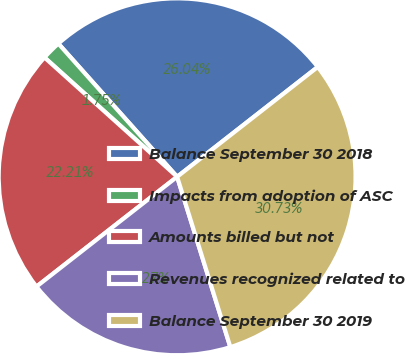Convert chart to OTSL. <chart><loc_0><loc_0><loc_500><loc_500><pie_chart><fcel>Balance September 30 2018<fcel>Impacts from adoption of ASC<fcel>Amounts billed but not<fcel>Revenues recognized related to<fcel>Balance September 30 2019<nl><fcel>26.04%<fcel>1.75%<fcel>22.21%<fcel>19.27%<fcel>30.73%<nl></chart> 